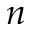<formula> <loc_0><loc_0><loc_500><loc_500>n</formula> 